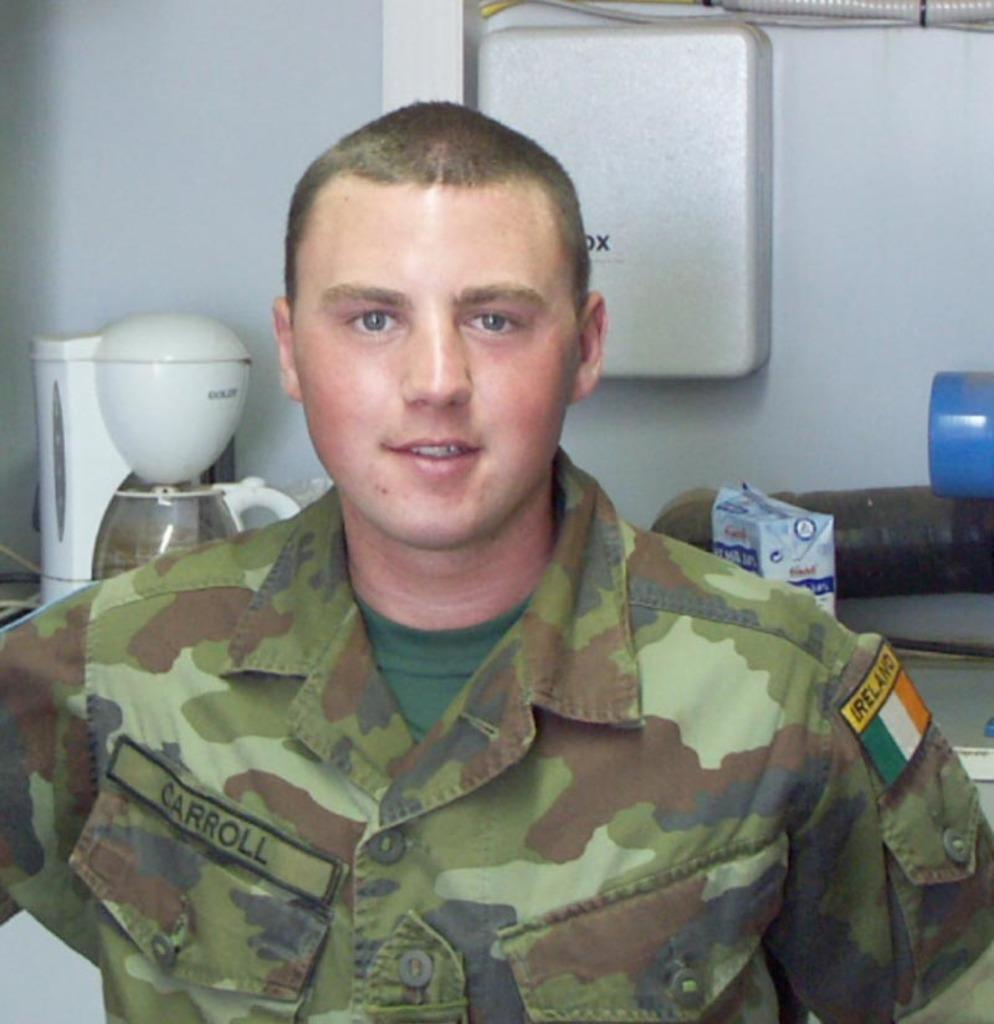<image>
Offer a succinct explanation of the picture presented. A man in a military uniform with an patch on his shoulder that says Ireland and one on his chest that says Carroll. 